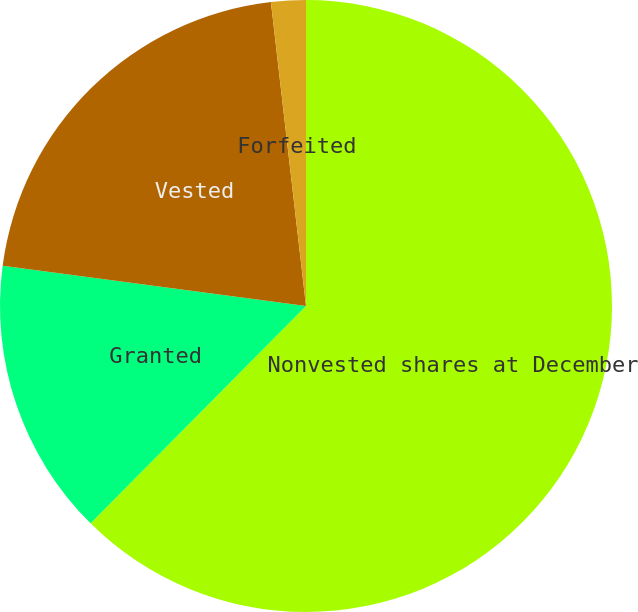<chart> <loc_0><loc_0><loc_500><loc_500><pie_chart><fcel>Nonvested shares at December<fcel>Granted<fcel>Vested<fcel>Forfeited<nl><fcel>62.43%<fcel>14.67%<fcel>21.07%<fcel>1.83%<nl></chart> 